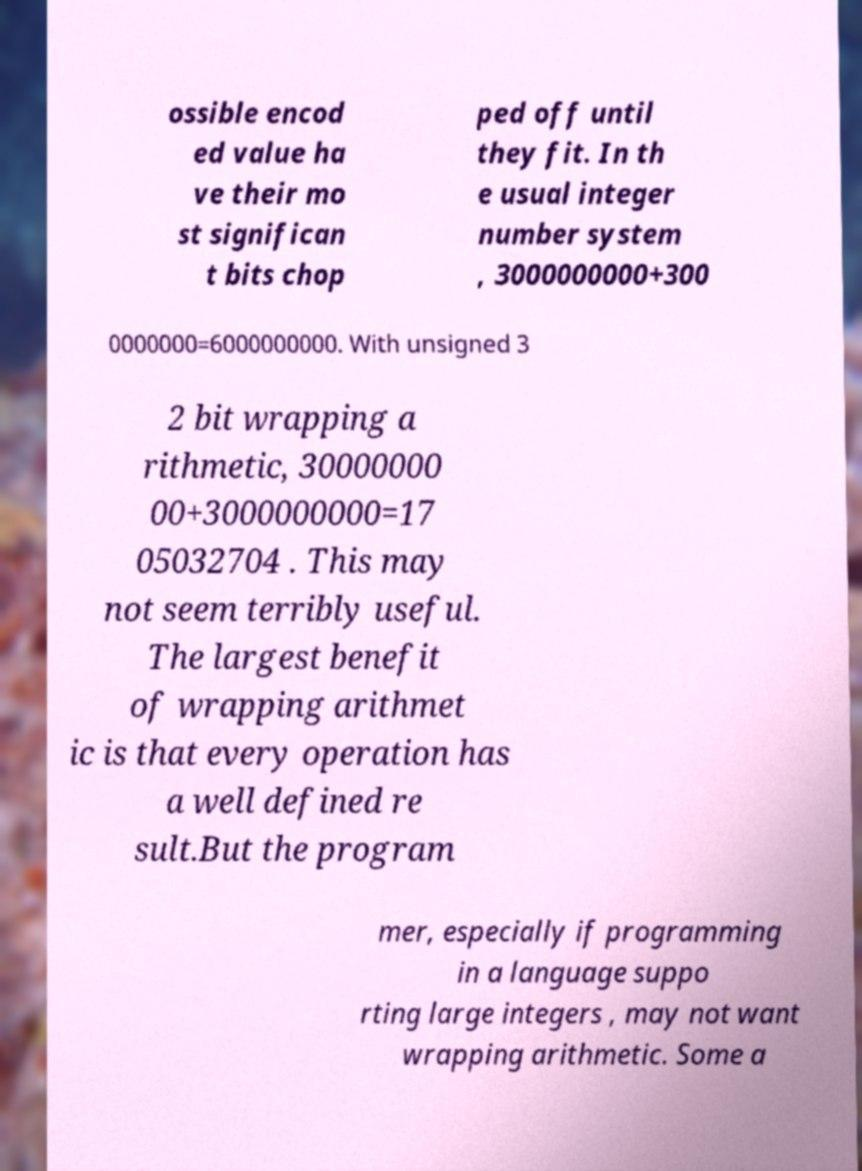For documentation purposes, I need the text within this image transcribed. Could you provide that? ossible encod ed value ha ve their mo st significan t bits chop ped off until they fit. In th e usual integer number system , 3000000000+300 0000000=6000000000. With unsigned 3 2 bit wrapping a rithmetic, 30000000 00+3000000000=17 05032704 . This may not seem terribly useful. The largest benefit of wrapping arithmet ic is that every operation has a well defined re sult.But the program mer, especially if programming in a language suppo rting large integers , may not want wrapping arithmetic. Some a 